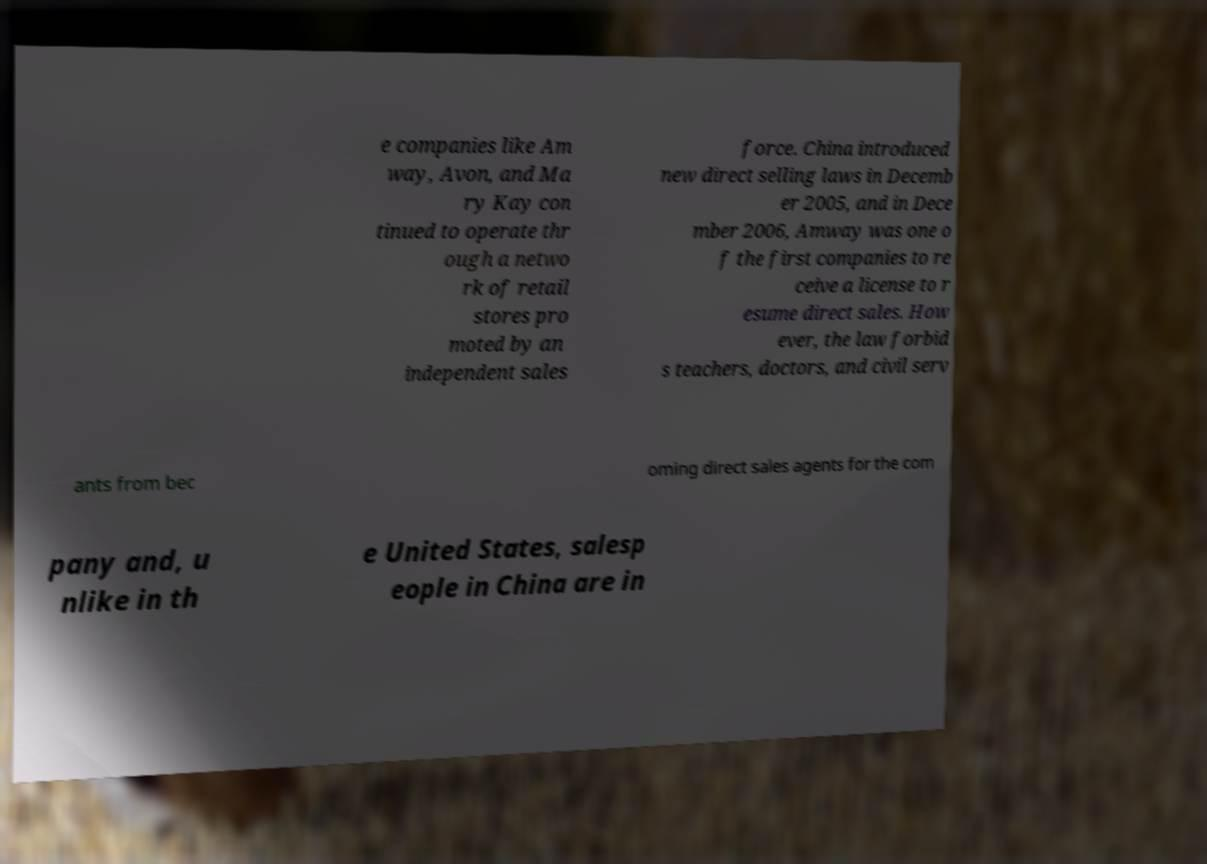There's text embedded in this image that I need extracted. Can you transcribe it verbatim? e companies like Am way, Avon, and Ma ry Kay con tinued to operate thr ough a netwo rk of retail stores pro moted by an independent sales force. China introduced new direct selling laws in Decemb er 2005, and in Dece mber 2006, Amway was one o f the first companies to re ceive a license to r esume direct sales. How ever, the law forbid s teachers, doctors, and civil serv ants from bec oming direct sales agents for the com pany and, u nlike in th e United States, salesp eople in China are in 